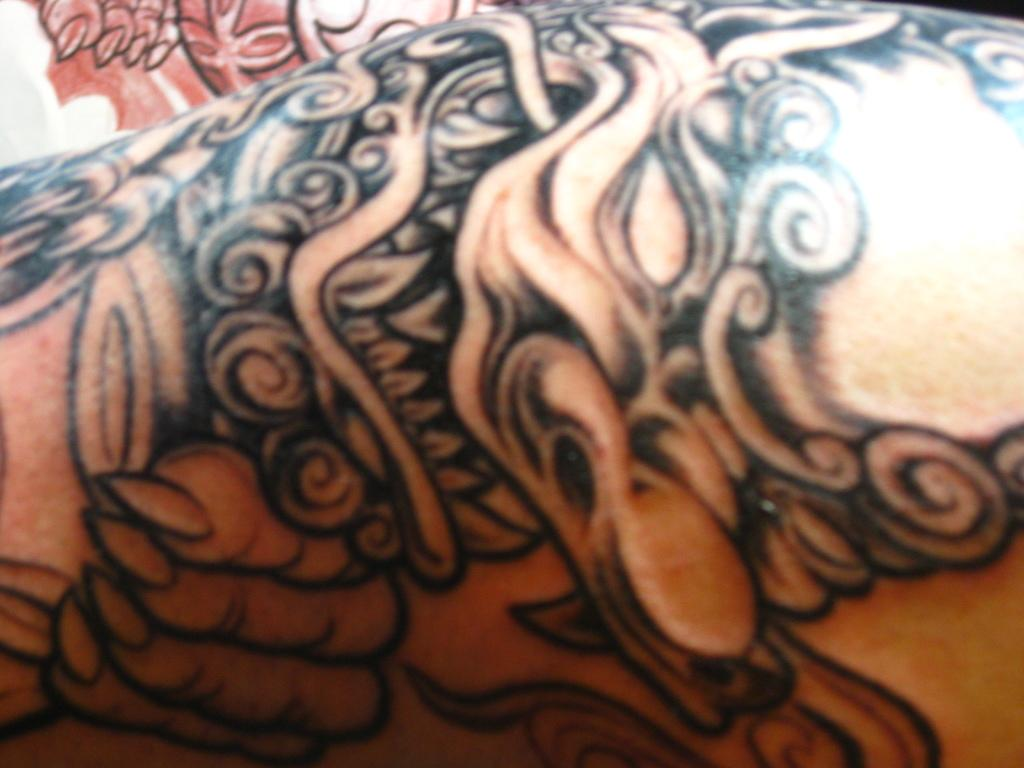What part of the human body is visible in the image? There is a human hand in the image. What feature can be seen on the hand? There is a tattoo on the hand. What is the relation between the tattoo and the disgust in the image? There is no mention of disgust in the image, and the tattoo is not related to any emotion or feeling. 